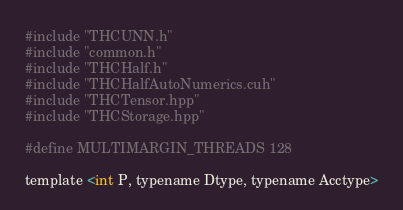Convert code to text. <code><loc_0><loc_0><loc_500><loc_500><_Cuda_>#include "THCUNN.h"
#include "common.h"
#include "THCHalf.h"
#include "THCHalfAutoNumerics.cuh"
#include "THCTensor.hpp"
#include "THCStorage.hpp"

#define MULTIMARGIN_THREADS 128

template <int P, typename Dtype, typename Acctype></code> 